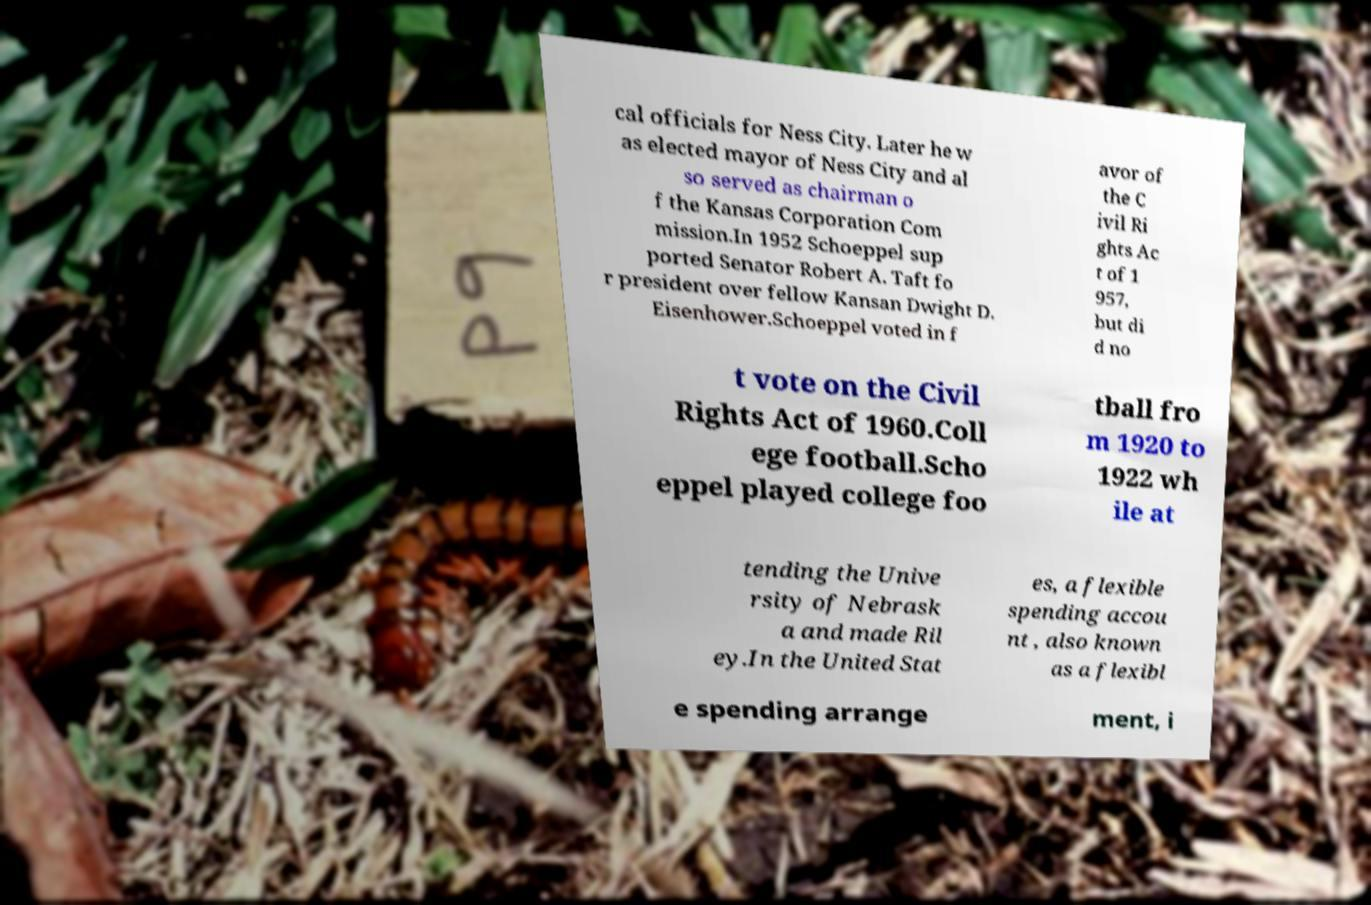Could you assist in decoding the text presented in this image and type it out clearly? cal officials for Ness City. Later he w as elected mayor of Ness City and al so served as chairman o f the Kansas Corporation Com mission.In 1952 Schoeppel sup ported Senator Robert A. Taft fo r president over fellow Kansan Dwight D. Eisenhower.Schoeppel voted in f avor of the C ivil Ri ghts Ac t of 1 957, but di d no t vote on the Civil Rights Act of 1960.Coll ege football.Scho eppel played college foo tball fro m 1920 to 1922 wh ile at tending the Unive rsity of Nebrask a and made Ril ey.In the United Stat es, a flexible spending accou nt , also known as a flexibl e spending arrange ment, i 